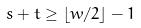<formula> <loc_0><loc_0><loc_500><loc_500>s + t \geq \lfloor w / 2 \rfloor - 1</formula> 